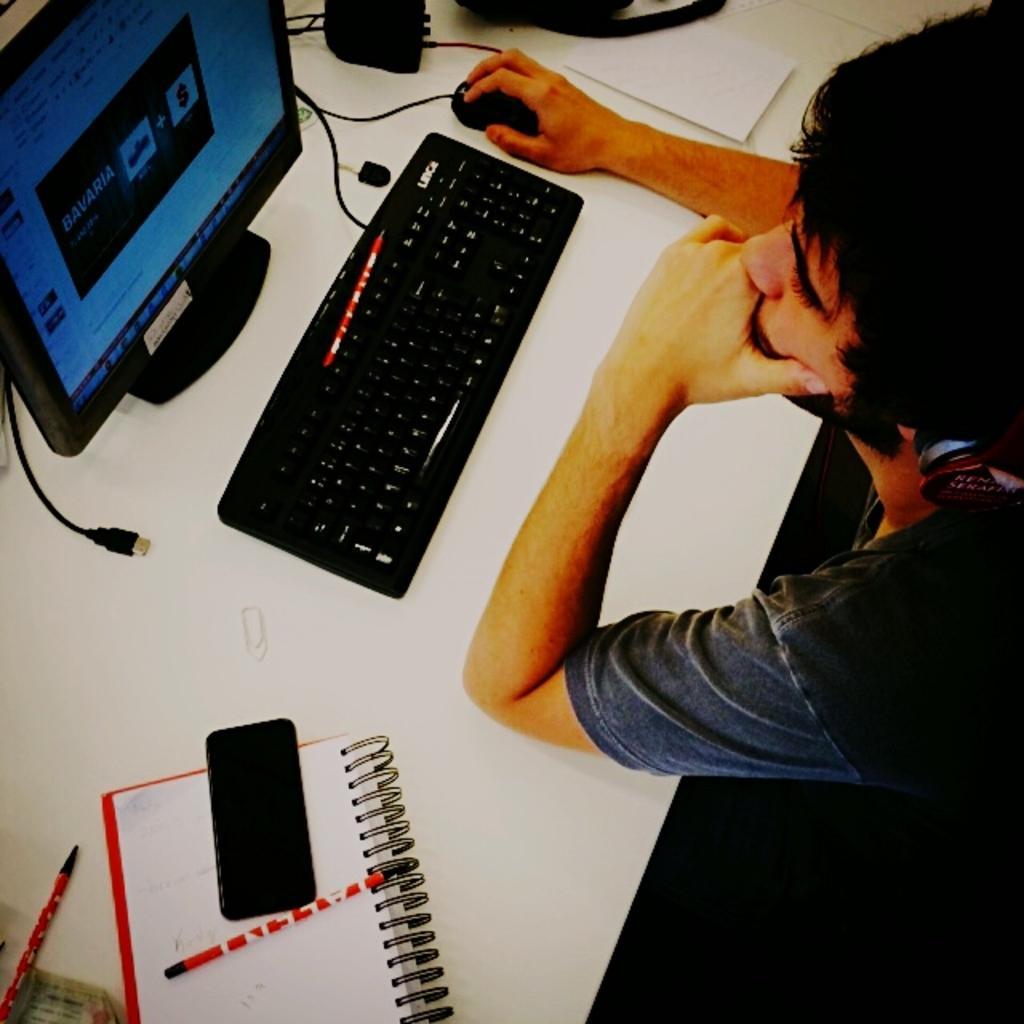Describe this image in one or two sentences. In this picture there is a man sitting in the chair, wearing a headset in front of a computer and a keyboard on, which were placed on the table. On the table there is a paper, book, mobile and pen here. 